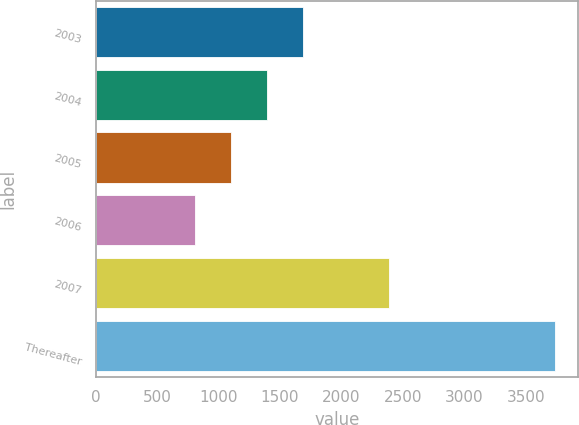Convert chart to OTSL. <chart><loc_0><loc_0><loc_500><loc_500><bar_chart><fcel>2003<fcel>2004<fcel>2005<fcel>2006<fcel>2007<fcel>Thereafter<nl><fcel>1688.4<fcel>1395.6<fcel>1102.8<fcel>810<fcel>2389<fcel>3738<nl></chart> 